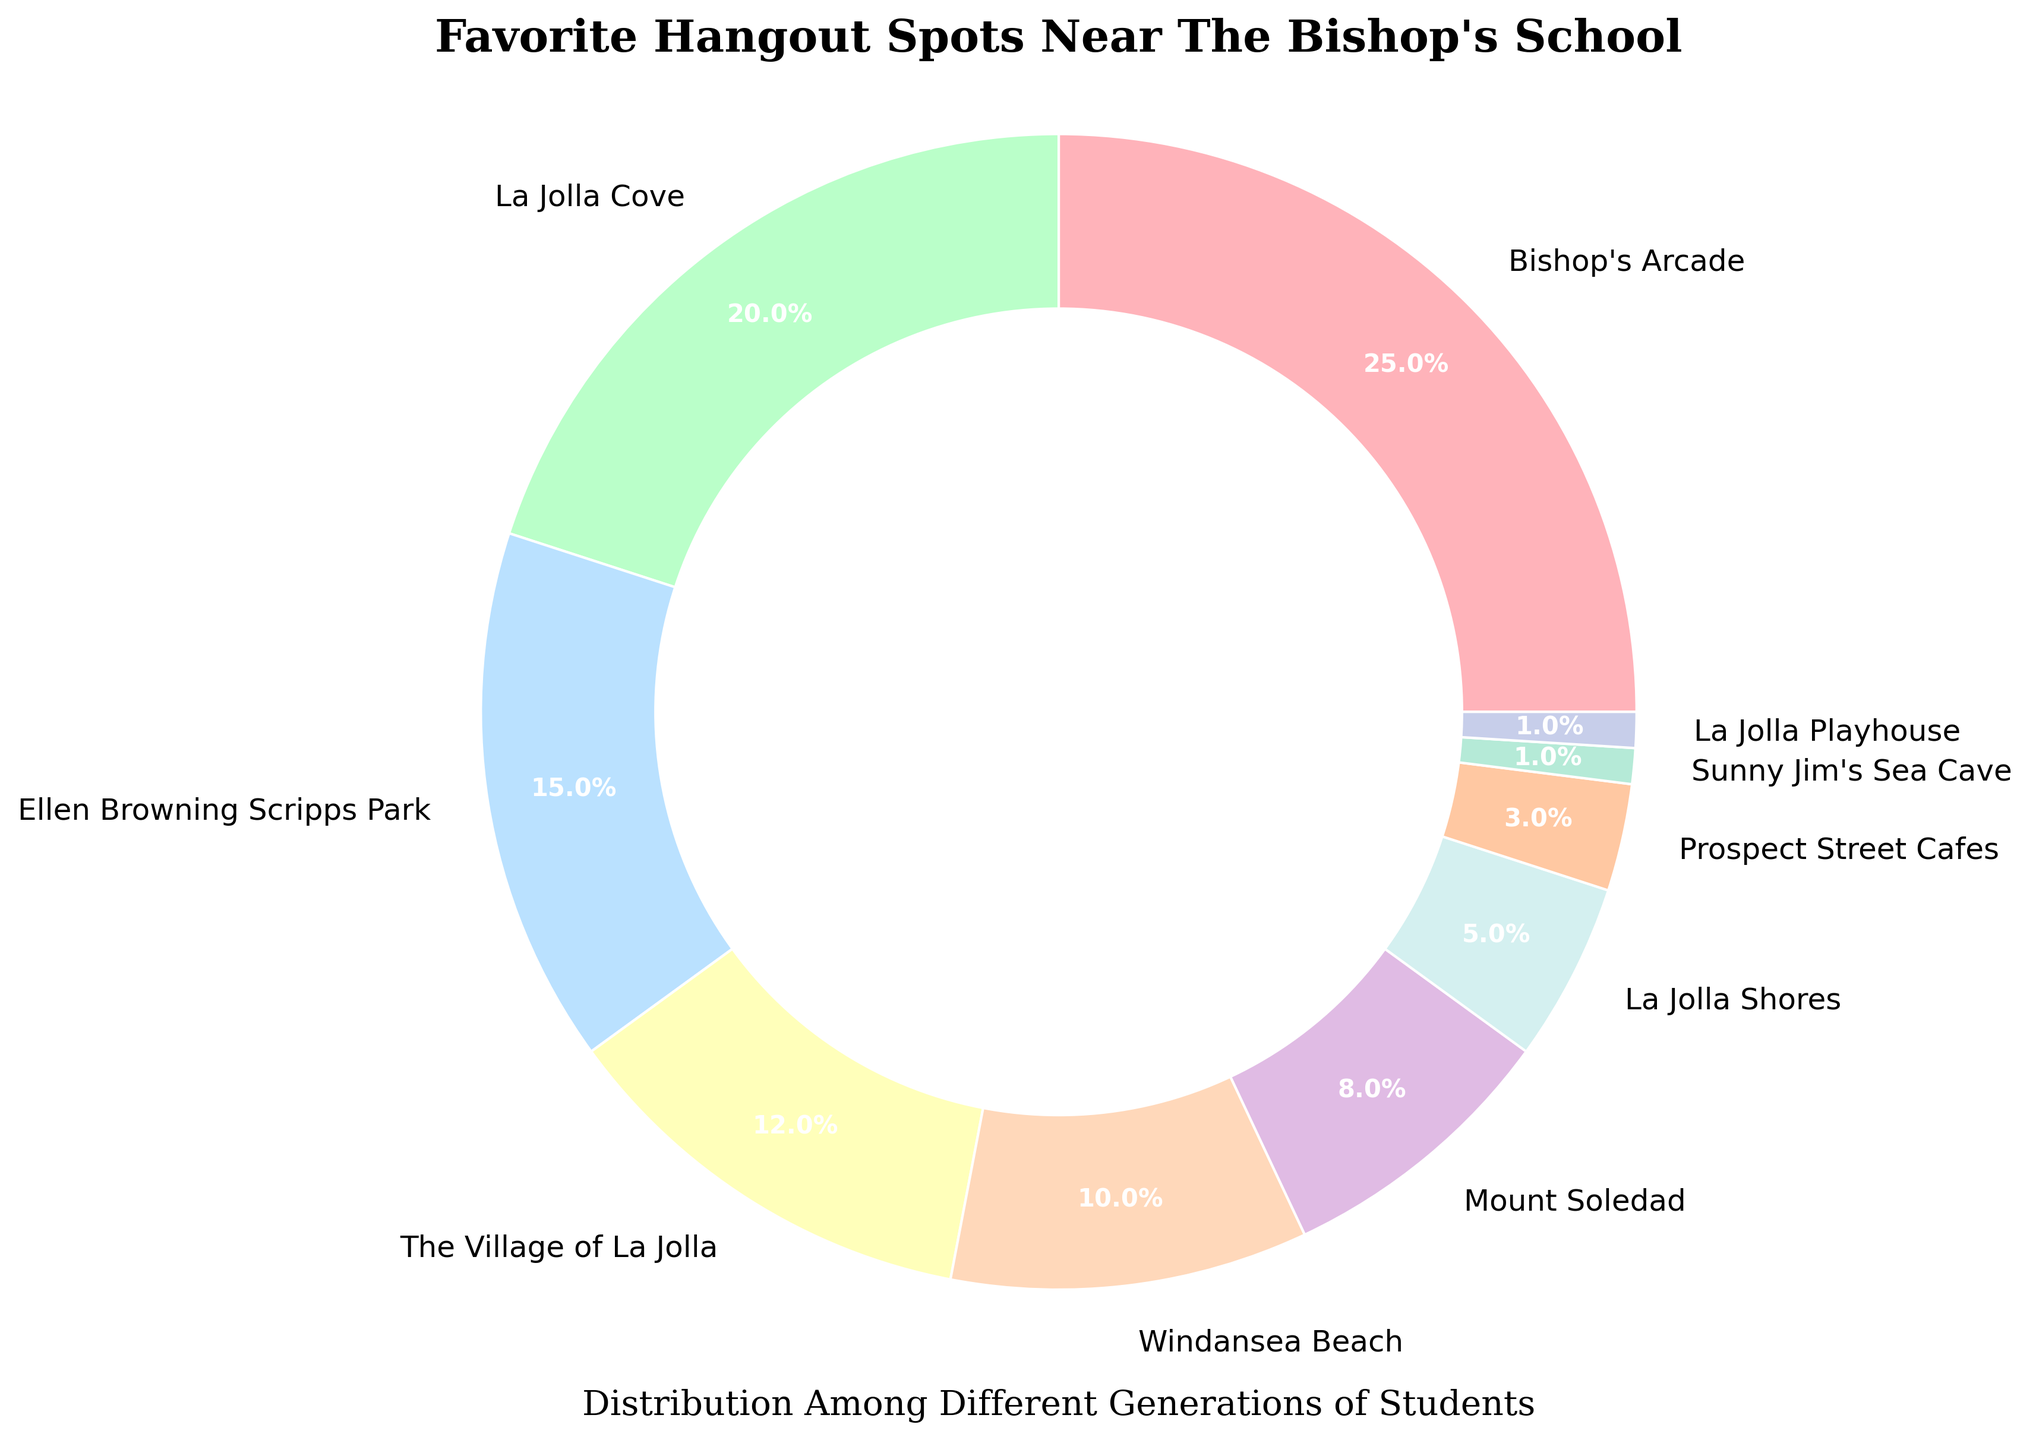What is the combined percentage of students who prefer Bishop's Arcade and La Jolla Cove? The figure shows that 25% of students favor Bishop's Arcade and 20% prefer La Jolla Cove. Adding these percentages, we get 25% + 20% = 45%.
Answer: 45% What hangout spot has the smallest percentage of students' preference? According to the figure, both Sunny Jim's Sea Cave and La Jolla Playhouse have the smallest percentages, each with 1%.
Answer: Sunny Jim's Sea Cave, La Jolla Playhouse Which hangout spot is more popular: La Jolla Shores or Windansea Beach? The figure shows that 10% of students favor Windansea Beach and 5% prefer La Jolla Shores. Since 10% is greater than 5%, Windansea Beach is more popular.
Answer: Windansea Beach What is the percentage difference between Ellen Browning Scripps Park and The Village of La Jolla? Ellen Browning Scripps Park has 15% and The Village of La Jolla has 12%. The difference is calculated as 15% - 12% = 3%.
Answer: 3% Which three locations have the highest student preference and what is their combined percentage? The top three locations by student preference are Bishop's Arcade (25%), La Jolla Cove (20%), and Ellen Browning Scripps Park (15%). Adding these, we get 25% + 20% + 15% = 60%.
Answer: Bishop's Arcade, La Jolla Cove, Ellen Browning Scripps Park; 60% What is the average percentage preference among the locations listed in the figure? Add all the percentages together: 25 + 20 + 15 + 12 + 10 + 8 + 5 + 3 + 1 + 1 = 100%. Since there are 10 locations, the average percentage is 100% / 10 = 10%.
Answer: 10% Which location has a higher preference, Mount Soledad or Prospect Street Cafes? The figure shows Mount Soledad has an 8% preference and Prospect Street Cafes have a 3% preference. Since 8% is greater than 3%, Mount Soledad is preferred.
Answer: Mount Soledad Listing from most to least popular, where does La Jolla Shores rank among all hangout spots? Arranging by percentages: Bishop's Arcade (25%), La Jolla Cove (20%), Ellen Browning Scripps Park (15%), The Village of La Jolla (12%), Windansea Beach (10%), Mount Soledad (8%), La Jolla Shores (5%), Prospect Street Cafes (3%), Sunny Jim's Sea Cave (1%), La Jolla Playhouse (1%). La Jolla Shores is 7th in order.
Answer: 7th If you combine the preferences for Windansea Beach and The Village of La Jolla, do they surpass the preference percentage for Bishop's Arcade? Windansea Beach has 10% and The Village of La Jolla has 12%. Their combined percentage is 10% + 12% = 22%. This is less than Bishop's Arcade's 25%, so they do not surpass it.
Answer: No 